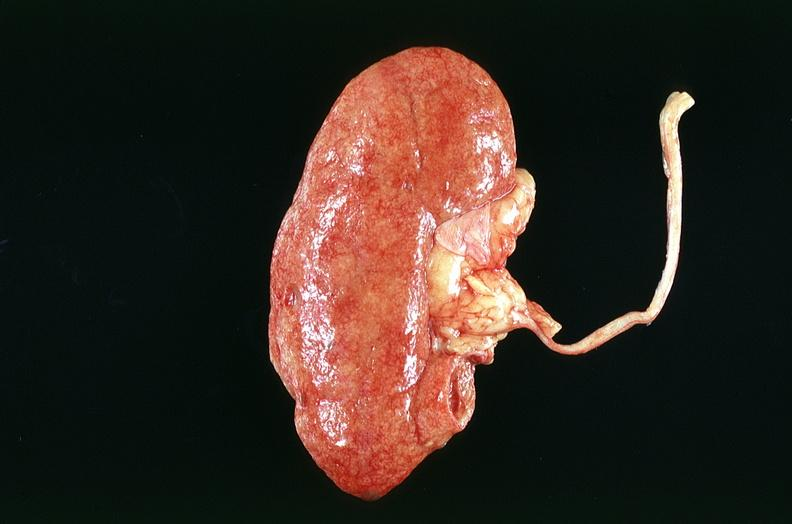where is this?
Answer the question using a single word or phrase. Urinary 